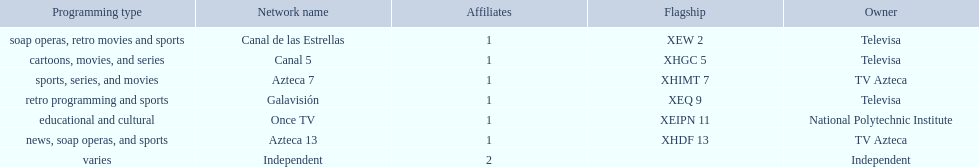How many networks does televisa own? 3. 